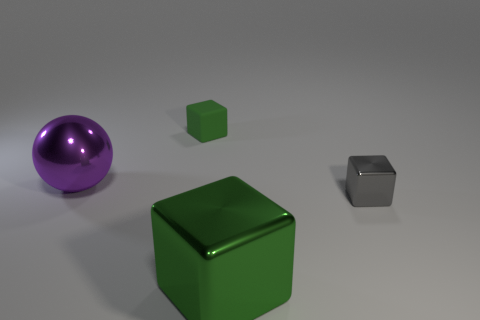There is another rubber cube that is the same color as the large block; what is its size?
Your response must be concise. Small. Is there anything else that is the same color as the big metallic sphere?
Keep it short and to the point. No. What is the color of the rubber cube?
Give a very brief answer. Green. What shape is the thing that is in front of the tiny block in front of the large purple thing?
Your answer should be compact. Cube. Is the number of green rubber objects less than the number of big brown balls?
Provide a short and direct response. No. Do the tiny gray thing and the small green thing have the same material?
Give a very brief answer. No. What color is the cube that is both on the left side of the gray thing and in front of the rubber thing?
Give a very brief answer. Green. Is there a red matte cube that has the same size as the matte thing?
Provide a short and direct response. No. There is a green object behind the big object in front of the large purple shiny sphere; what is its size?
Ensure brevity in your answer.  Small. Are there fewer big green things that are in front of the tiny metallic object than small green objects?
Give a very brief answer. No. 